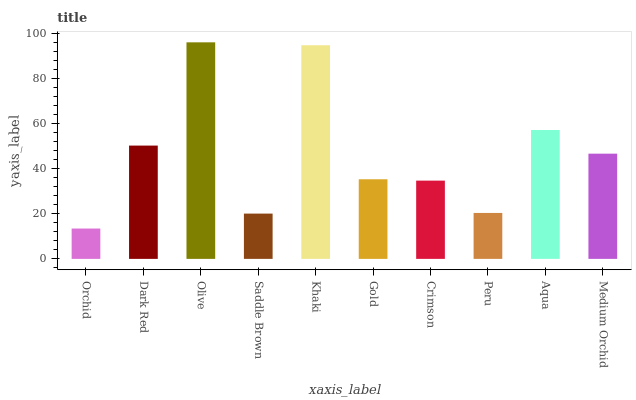Is Orchid the minimum?
Answer yes or no. Yes. Is Olive the maximum?
Answer yes or no. Yes. Is Dark Red the minimum?
Answer yes or no. No. Is Dark Red the maximum?
Answer yes or no. No. Is Dark Red greater than Orchid?
Answer yes or no. Yes. Is Orchid less than Dark Red?
Answer yes or no. Yes. Is Orchid greater than Dark Red?
Answer yes or no. No. Is Dark Red less than Orchid?
Answer yes or no. No. Is Medium Orchid the high median?
Answer yes or no. Yes. Is Gold the low median?
Answer yes or no. Yes. Is Aqua the high median?
Answer yes or no. No. Is Crimson the low median?
Answer yes or no. No. 